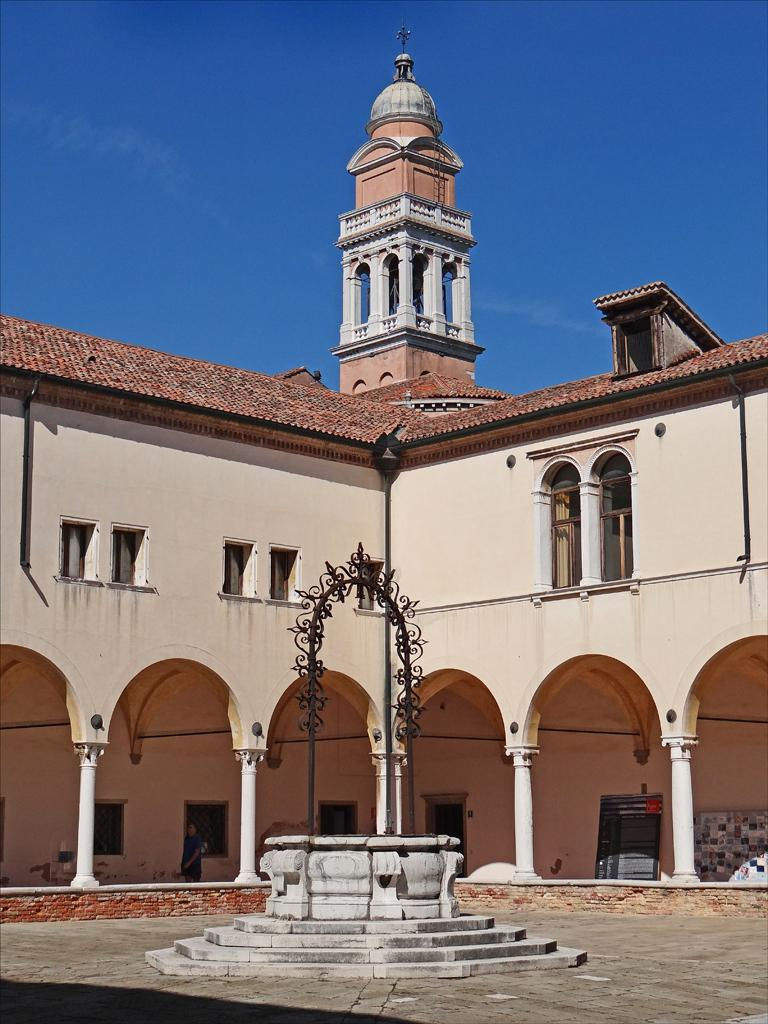What is the main structure in the center of the image? There is a building in the center of the image. What can be seen in the foreground of the image? There is a fountain and stairs in the foreground of the image. What is located at the bottom of the image? There is a walkway at the bottom of the image. What is visible at the top of the image? The sky is visible at the top of the image. Where is the jail located in the image? There is no jail present in the image. How many clovers can be seen growing near the fountain? There are no clovers visible in the image. 